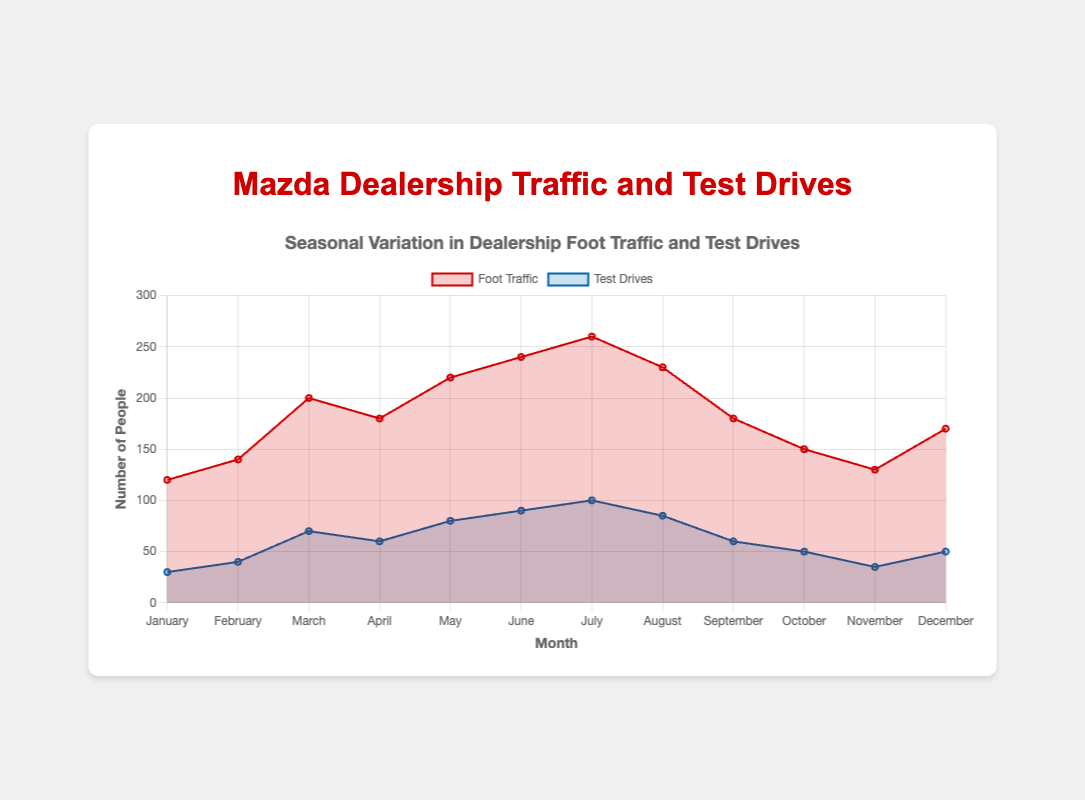What is the title of the chart? The title is usually located at the top of the chart. In this figure, the title clearly states the main focus.
Answer: Seasonal Variation in Dealership Foot Traffic and Test Drives Which month had the highest foot traffic? Look at the data points for each month; July has the tallest point in the foot traffic dataset.
Answer: July What is the difference in test drives between March and April? Locate the values for March and April under test drives, then subtract the value for April from March: 70 - 60 = 10.
Answer: 10 Which month had the least number of test drives? Compare all the data points for test drives across months; January has 30 which is the lowest.
Answer: January During which month are foot traffic and test drives both equal to 50? Check each month in the chart to find where both foot traffic and test drives are 50. October is the only month where test drives are 50, but foot traffic never actually equates specifically 50 in any month from the provided data.
Answer: None How does the test drive trend in June compare to July? Observe the height of the bars in the test drives section from June to July; there's an increase from 90 to 100.
Answer: Increased What is the average foot traffic across all months? Sum all foot traffic values and divide by the number of months (12): (120 +140 + 200 + 180 + 220 + 240 + 260 + 230 + 180 + 150 + 130 + 170) / 12 = 1920 / 12 = 160.
Answer: 160 Is there a month where the number of test drives is exactly half the number of foot traffic? Compare each month’s test drives to half its foot traffic; in August, test drives are 85 which is not half of 230. So, there's no exact month where the test drives are half the foot traffic.
Answer: No How did the foot traffic change from June to July? Observe the heights of the bars for both months in the foot traffic dataset; it increased from 240 to 260.
Answer: Increased What is the total number of test drives in the first quarter (January to March)? Add the test drive values for January, February, and March: 30 + 40 + 70 = 140.
Answer: 140 